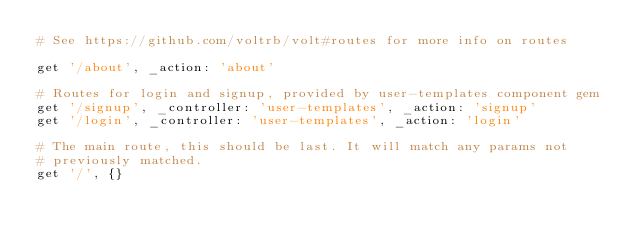<code> <loc_0><loc_0><loc_500><loc_500><_Ruby_># See https://github.com/voltrb/volt#routes for more info on routes

get '/about', _action: 'about'

# Routes for login and signup, provided by user-templates component gem
get '/signup', _controller: 'user-templates', _action: 'signup'
get '/login', _controller: 'user-templates', _action: 'login'

# The main route, this should be last. It will match any params not
# previously matched.
get '/', {}
</code> 